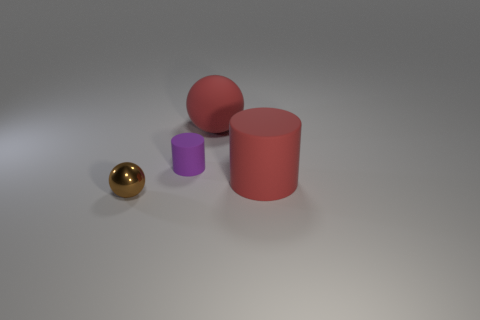Add 2 tiny red rubber balls. How many objects exist? 6 Subtract all red balls. How many balls are left? 1 Subtract 1 spheres. How many spheres are left? 1 Subtract all green cylinders. How many brown balls are left? 1 Add 4 large brown metal objects. How many large brown metal objects exist? 4 Subtract 0 gray balls. How many objects are left? 4 Subtract all brown balls. Subtract all gray cylinders. How many balls are left? 1 Subtract all cyan shiny spheres. Subtract all small brown balls. How many objects are left? 3 Add 3 brown objects. How many brown objects are left? 4 